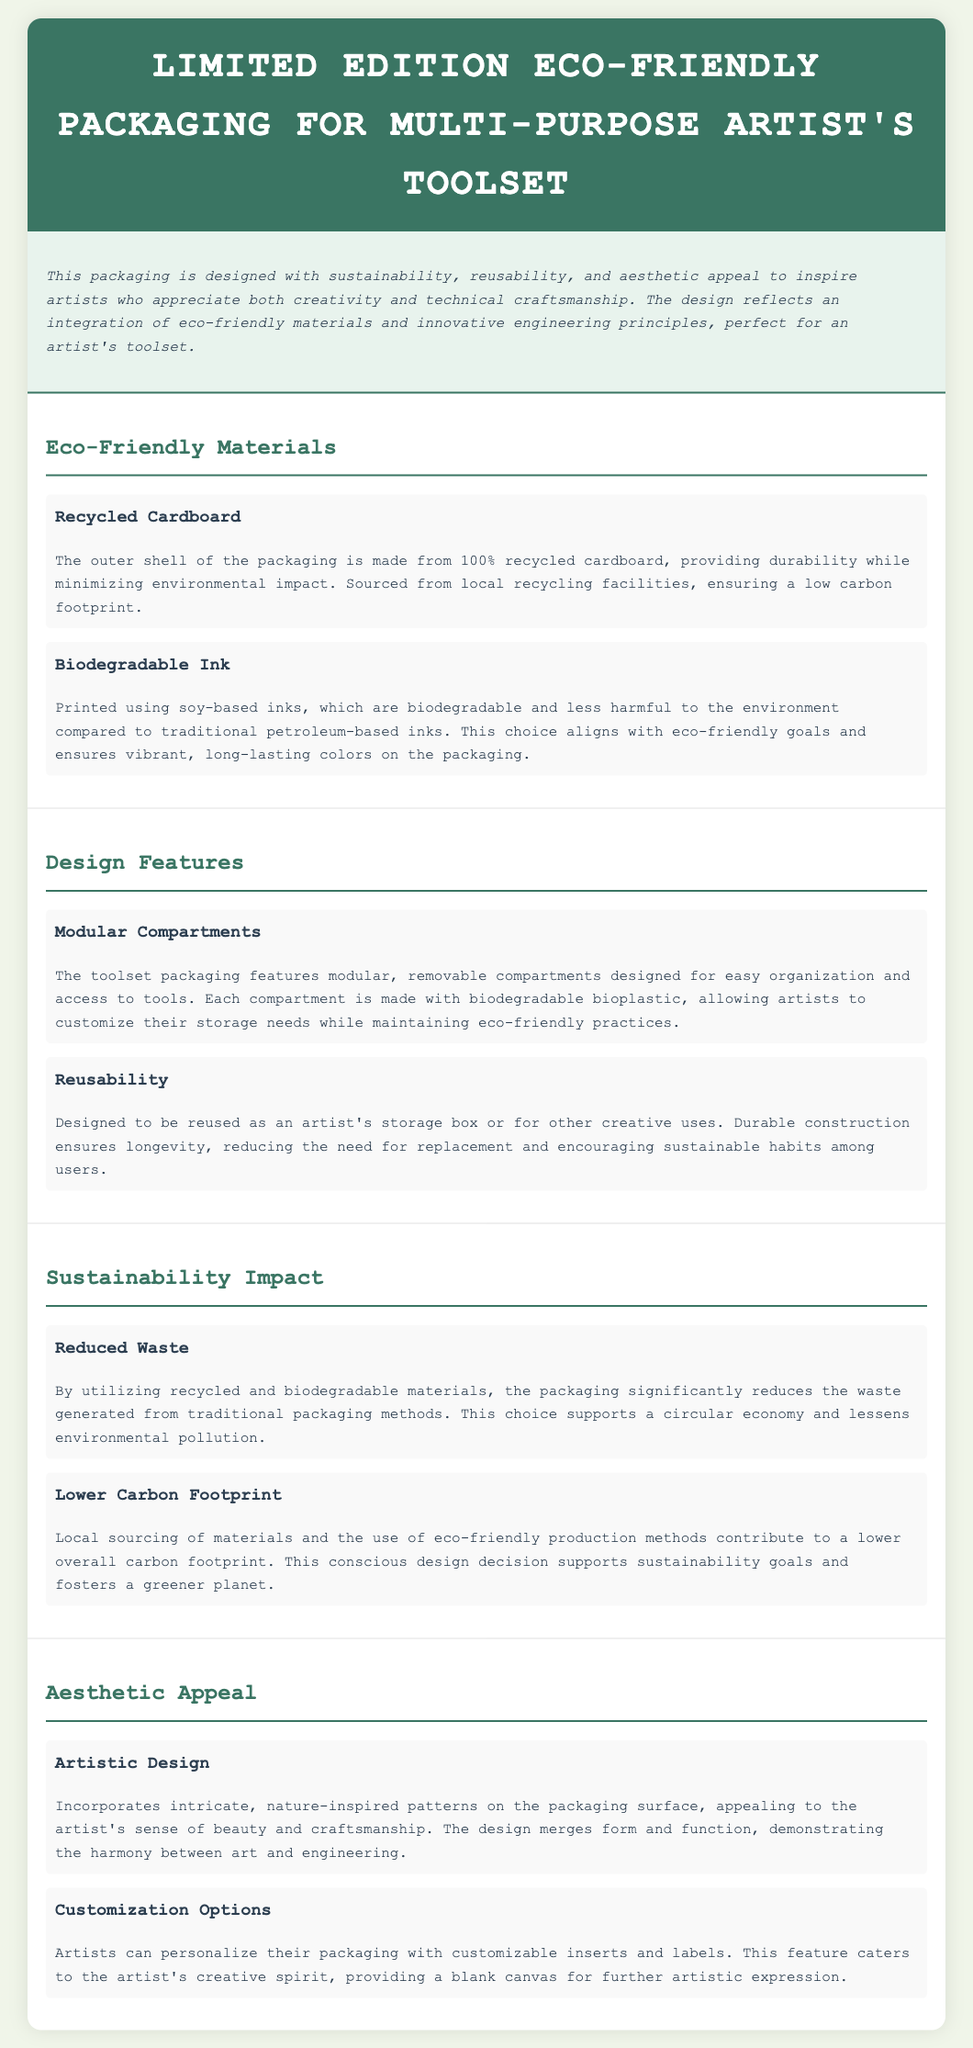What is the outer shell made from? The outer shell of the packaging is made from 100% recycled cardboard, which provides durability while minimizing environmental impact.
Answer: 100% recycled cardboard What type of ink is used for printing? The packaging is printed using soy-based inks, which are biodegradable and less harmful to the environment compared to traditional petroleum-based inks.
Answer: Biodegradable ink What is the purpose of modular compartments? The toolset packaging features modular, removable compartments designed for easy organization and access to tools, allowing artists to customize their storage needs.
Answer: Easy organization What does the packaging significantly reduce? By utilizing recycled and biodegradable materials, the packaging significantly reduces the waste generated from traditional packaging methods, supporting a circular economy.
Answer: Waste What is a feature that allows personalized artistic expression? The packaging includes customizable inserts and labels, catering to the artist's creative spirit and providing a blank canvas for further artistic expression.
Answer: Customizable options 